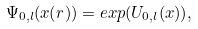Convert formula to latex. <formula><loc_0><loc_0><loc_500><loc_500>\Psi _ { 0 , l } ( x ( r ) ) = e x p ( U _ { 0 , l } ( x ) ) ,</formula> 